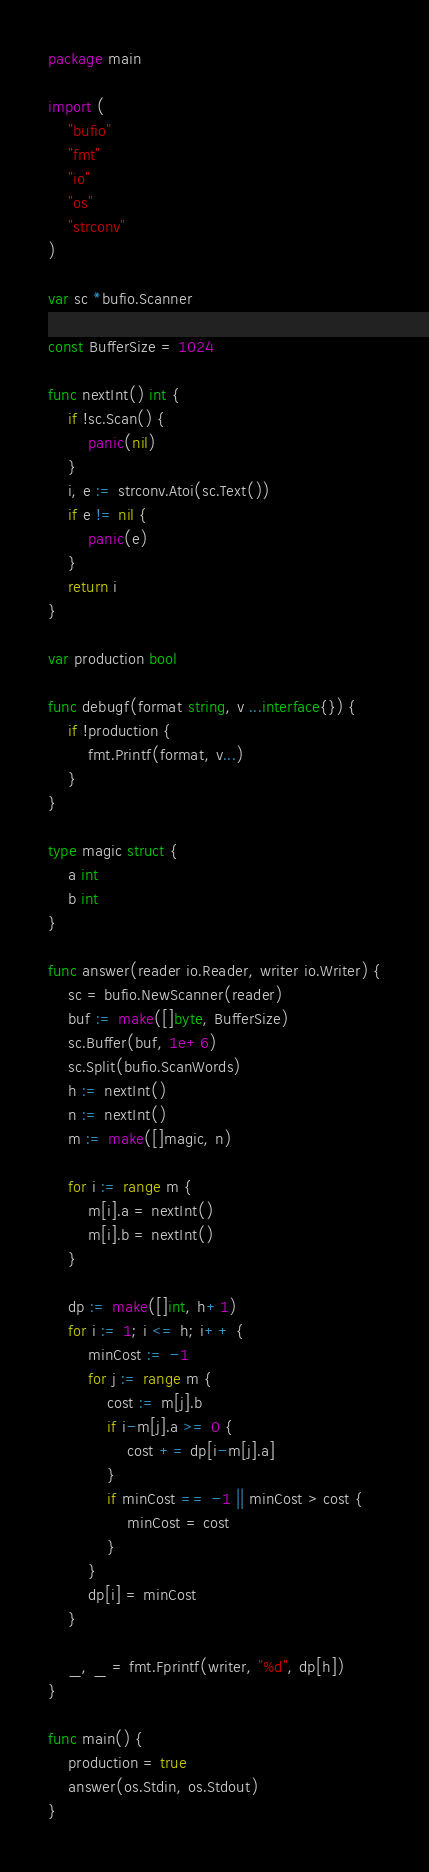Convert code to text. <code><loc_0><loc_0><loc_500><loc_500><_Go_>package main

import (
	"bufio"
	"fmt"
	"io"
	"os"
	"strconv"
)

var sc *bufio.Scanner

const BufferSize = 1024

func nextInt() int {
	if !sc.Scan() {
		panic(nil)
	}
	i, e := strconv.Atoi(sc.Text())
	if e != nil {
		panic(e)
	}
	return i
}

var production bool

func debugf(format string, v ...interface{}) {
	if !production {
		fmt.Printf(format, v...)
	}
}

type magic struct {
	a int
	b int
}

func answer(reader io.Reader, writer io.Writer) {
	sc = bufio.NewScanner(reader)
	buf := make([]byte, BufferSize)
	sc.Buffer(buf, 1e+6)
	sc.Split(bufio.ScanWords)
	h := nextInt()
	n := nextInt()
	m := make([]magic, n)

	for i := range m {
		m[i].a = nextInt()
		m[i].b = nextInt()
	}

	dp := make([]int, h+1)
	for i := 1; i <= h; i++ {
		minCost := -1
		for j := range m {
			cost := m[j].b
			if i-m[j].a >= 0 {
				cost += dp[i-m[j].a]
			}
			if minCost == -1 || minCost > cost {
				minCost = cost
			}
		}
		dp[i] = minCost
	}

	_, _ = fmt.Fprintf(writer, "%d", dp[h])
}

func main() {
	production = true
	answer(os.Stdin, os.Stdout)
}
</code> 